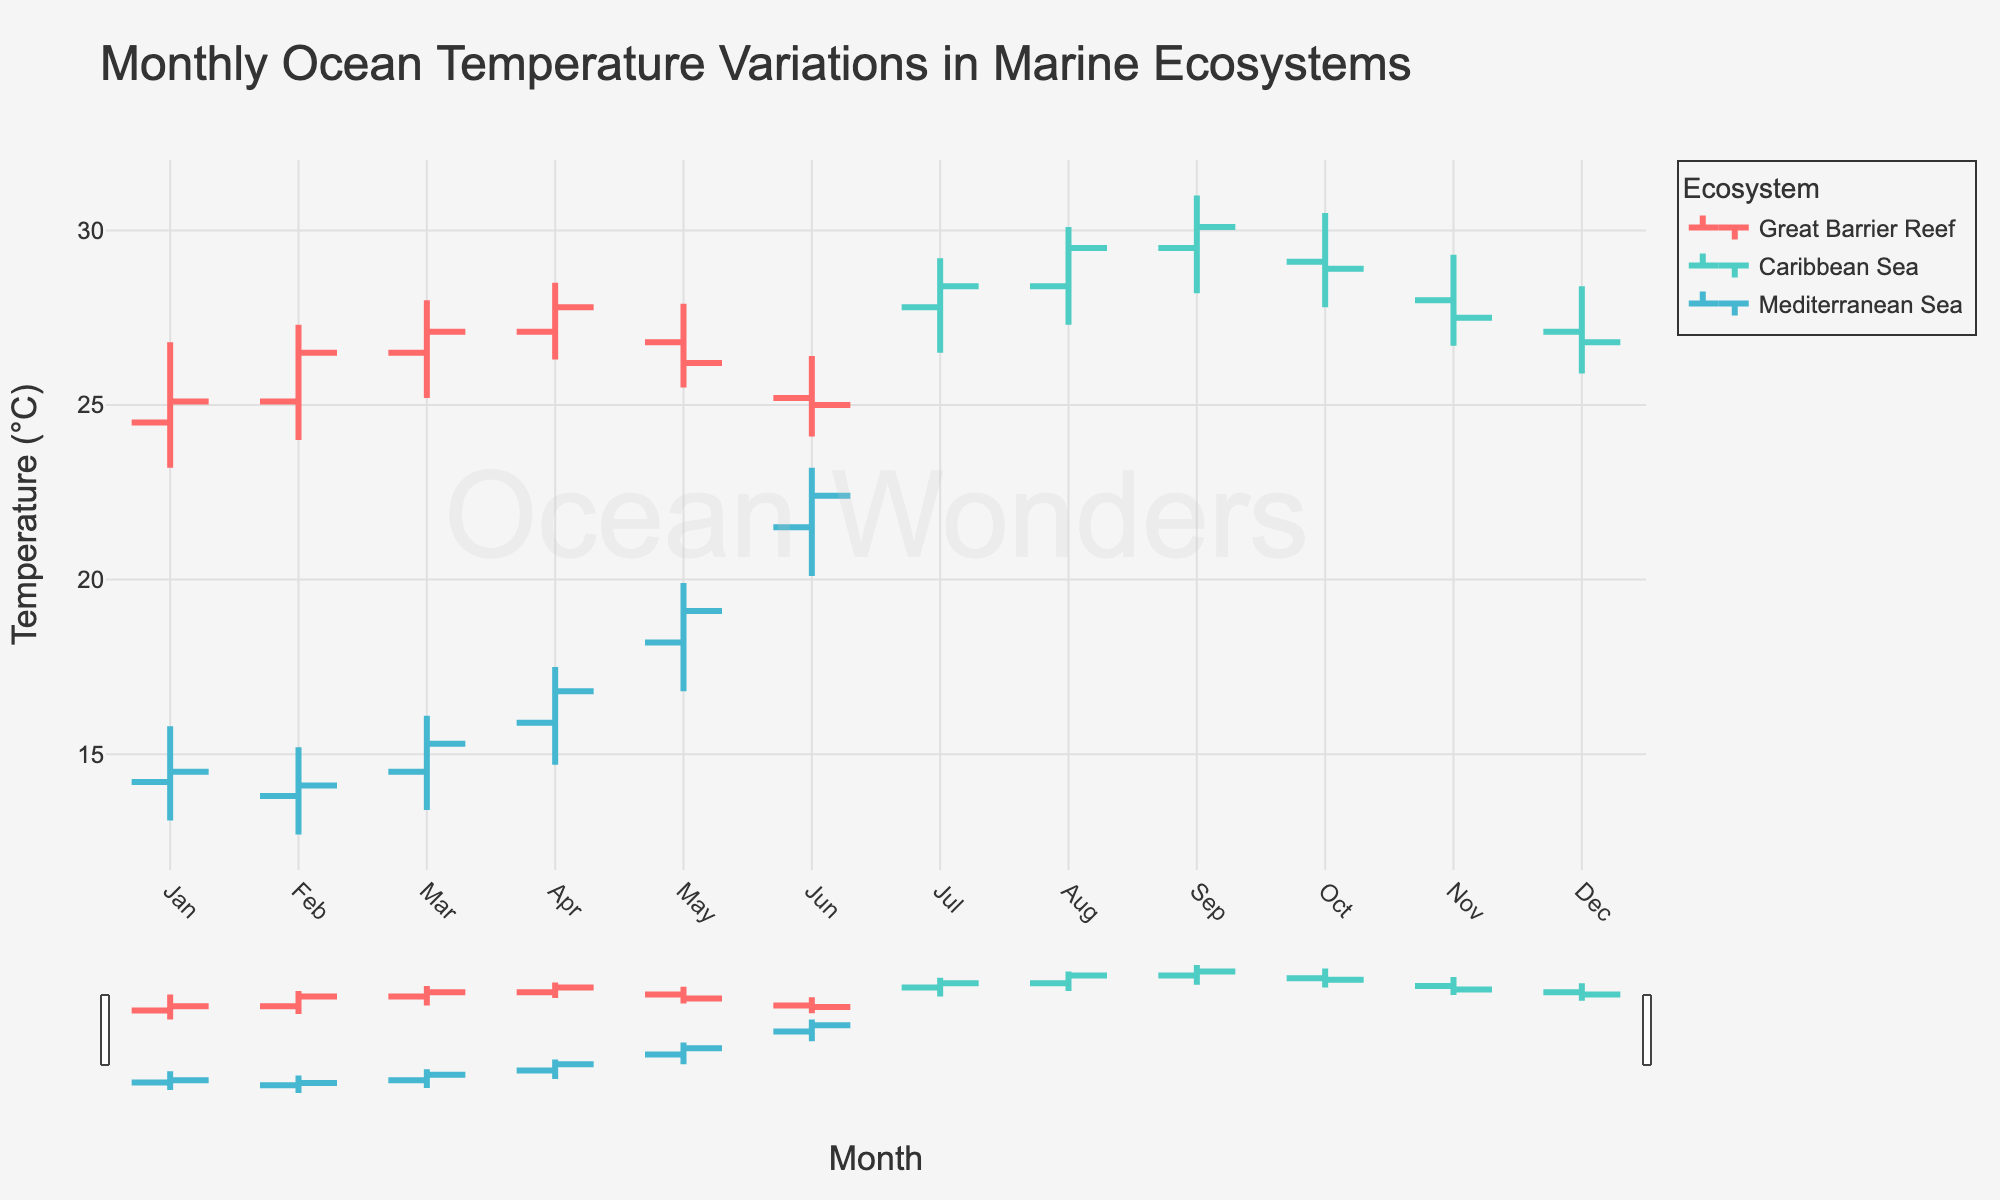What is the title of the chart? The title is usually displayed at the top of the chart. Looking at the figure, the title is read as 'Monthly Ocean Temperature Variations in Marine Ecosystems'.
Answer: Monthly Ocean Temperature Variations in Marine Ecosystems Which ecosystem has the highest recorded temperature? Since the Caribbean Sea shows the highest recorded temperatures, we look at the 'high' value for each month. The highest temperature is in the Caribbean Sea in September with a value of 31.0°C.
Answer: Caribbean Sea What month shows the highest temperature in the Mediterranean Sea? We examine the 'high' data points for the Mediterranean Sea. The highest temperature recorded is 23.2°C, which occurs in June.
Answer: June How does the temperature trend in the Great Barrier Reef change from April to June? In April, the 'close' temperature is 27.8°C, and it changes to 26.2°C in May and 25.0°C in June. This shows a continuous decrease over these months.
Answer: Decreasing Compare the 'open' temperature of the Great Barrier Reef in March and April. Which month has a higher 'open' temperature? In March, the 'open' temperature is 26.5°C, while in April, it is 27.1°C. Comparing these, April has a higher 'open' temperature.
Answer: April What is the temperature range (high - low) for the Caribbean Sea in August? The 'high' temperature for the Caribbean Sea in August is 30.1°C and the 'low' is 27.3°C. Subtracting these gives 30.1°C - 27.3°C = 2.8°C.
Answer: 2.8°C Which month shows the lowest 'close' temperature for the Caribbean Sea? The 'close' temperature in December is 26.8°C, which is lower than in other months.
Answer: December What is the average 'close' temperature for the Great Barrier Reef across all months? The 'close' temperatures for the Great Barrier Reef are: 25.1, 26.5, 27.1, 27.8, 26.2, 25.0. Adding these gives 157.7, and dividing by 6 (number of months) gives approximately 26.28°C.
Answer: 26.28°C How does the 'open' temperature in the Caribbean Sea in November compare to the 'close' temperature in December? The 'open' temperature in November is 28.0°C, while the 'close' temperature in December is 26.8°C. 28.0 is greater than 26.8.
Answer: Greater Which two ecosystems are included in the chart for the month of January? Looking at the ecosystems listed for January, the Great Barrier Reef and Mediterranean Sea are included.
Answer: Great Barrier Reef and Mediterranean Sea 